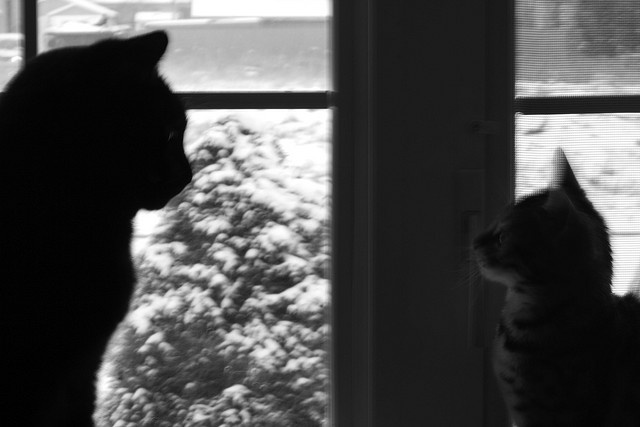Describe the objects in this image and their specific colors. I can see cat in silver, black, gray, darkgray, and lightgray tones and cat in silver, black, gray, darkgray, and lightgray tones in this image. 